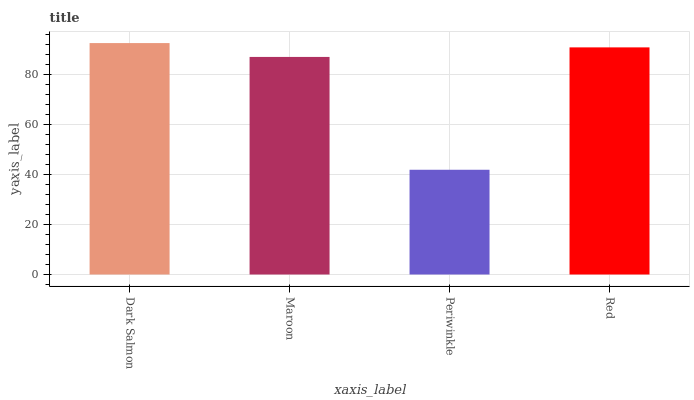Is Periwinkle the minimum?
Answer yes or no. Yes. Is Dark Salmon the maximum?
Answer yes or no. Yes. Is Maroon the minimum?
Answer yes or no. No. Is Maroon the maximum?
Answer yes or no. No. Is Dark Salmon greater than Maroon?
Answer yes or no. Yes. Is Maroon less than Dark Salmon?
Answer yes or no. Yes. Is Maroon greater than Dark Salmon?
Answer yes or no. No. Is Dark Salmon less than Maroon?
Answer yes or no. No. Is Red the high median?
Answer yes or no. Yes. Is Maroon the low median?
Answer yes or no. Yes. Is Dark Salmon the high median?
Answer yes or no. No. Is Dark Salmon the low median?
Answer yes or no. No. 